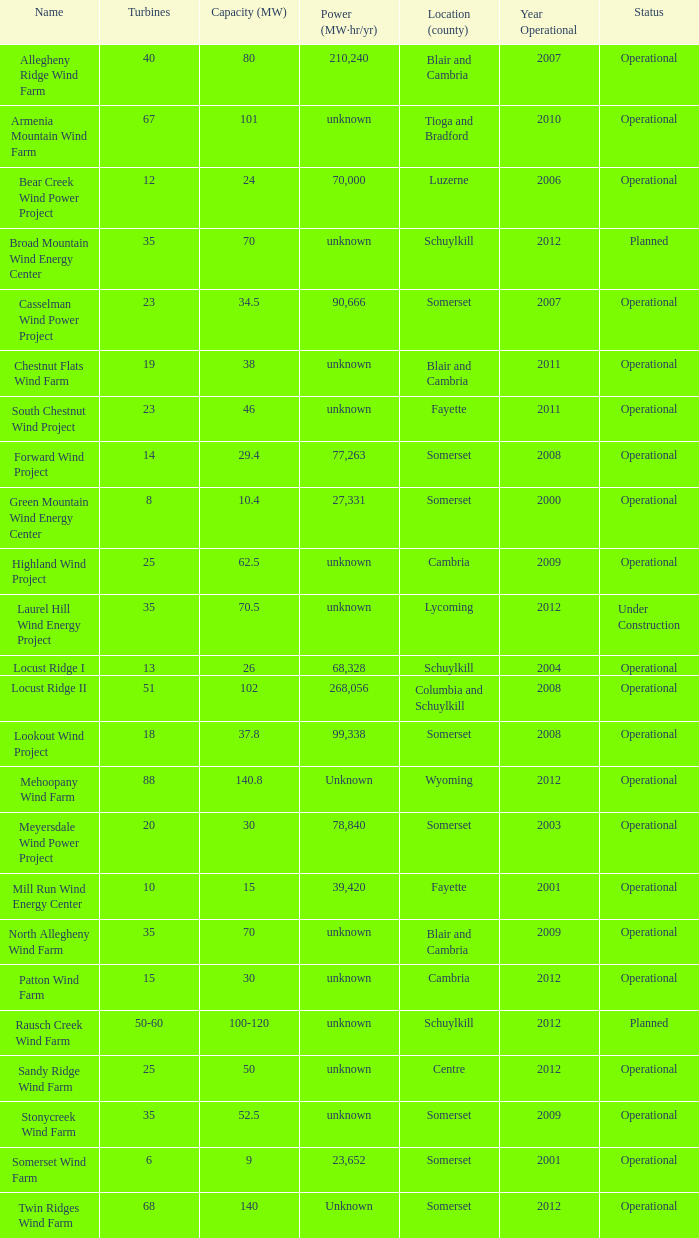What areas are deemed to be at the center? Unknown. 